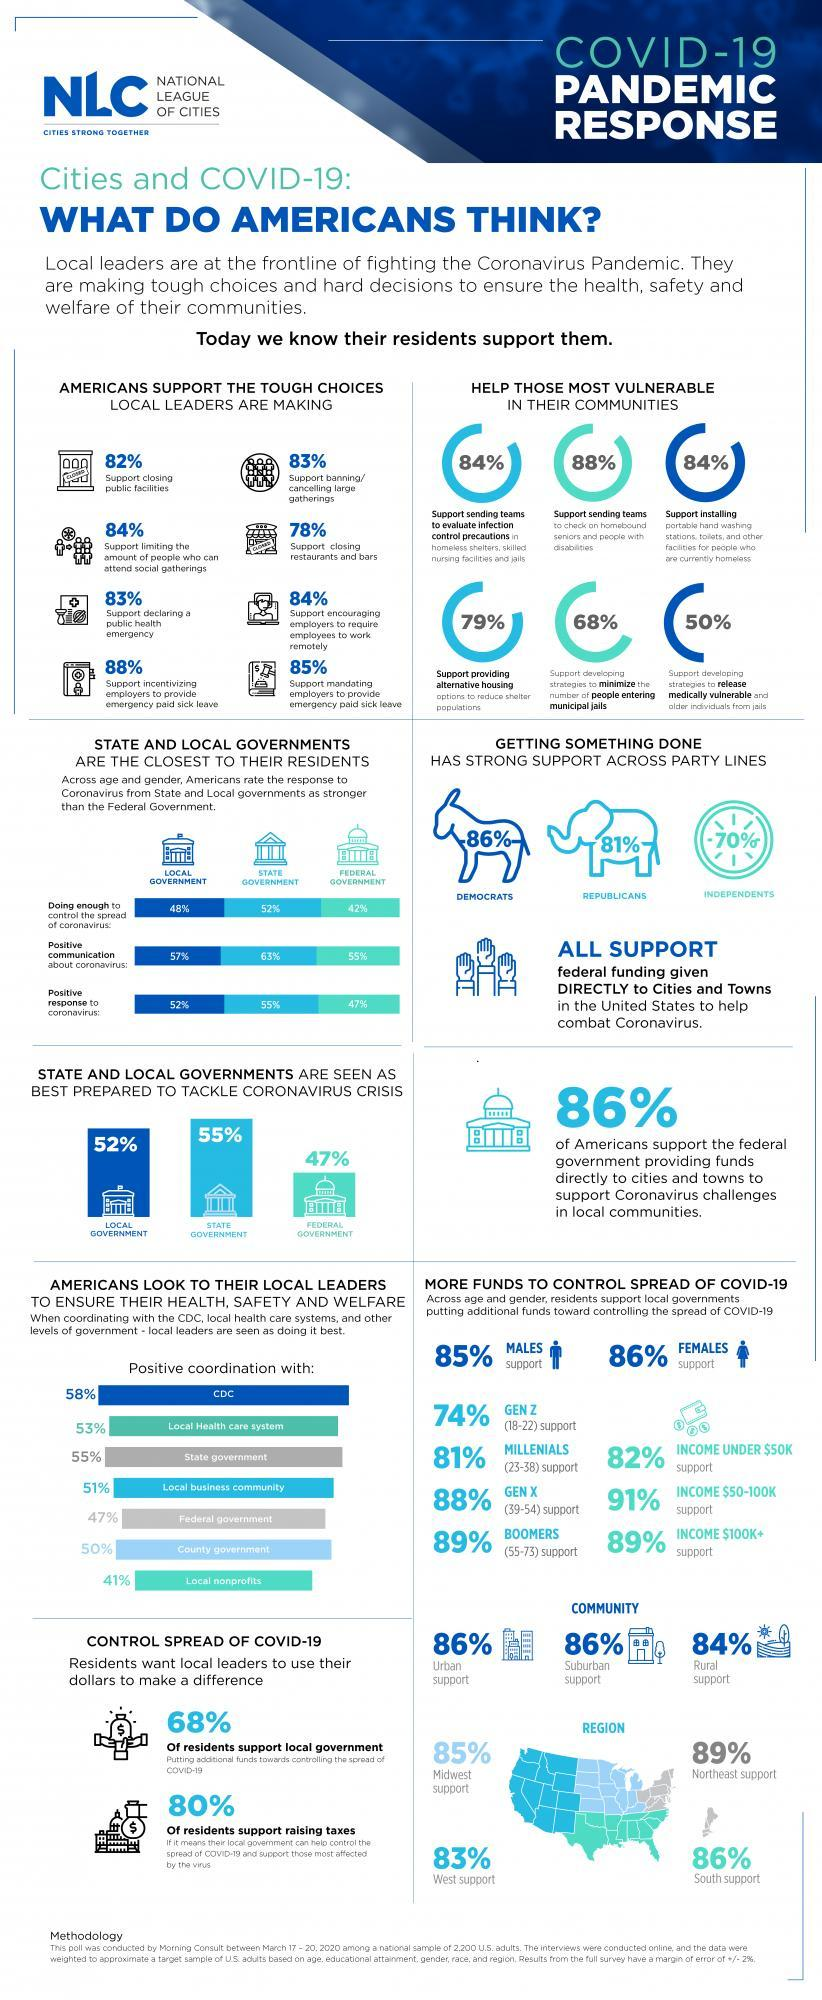What percentage of Americans thinks that the federal government not responded to coronavirus positively?
Answer the question with a short phrase. 53% what percentage of women does not support more funds to control the spread of COVID-19? 14 what percentage of generation z does not support more funds to control the spread of COVID-19? 26% What percentage of Americans thinks that the state government not responded to coronavirus positively? 48% What percentage of Americans thinks that effort taken by state government to control the spread of coronavirus is not enough? 48% What percentage of Americans thinks that effort taken by state government to control the spread of coronavirus is enough? 52 What percentage of Americans thinks that effort taken by federal government to control the spread of coronavirus is enough? 42 What percent of residents does not support raising taxes? 20 What percent of residents does not support federal government providing funds directly to cities and towns? 14 What percentage of Americans thinks that effort taken by the federal government to control the spread of coronavirus is not enough? 58% What percentage of Americans thinks that the state government not responded to coronavirus positively? 45 What percent of residents does not support declaring a public health emergency?? 17% What percent of residents does not support closing restaurants and bars? 22 What percent of residents does not support local government? 32 What percent of residents does not support closing public facilities? 18% what percentage of generation x does not support more funds to control the spread of COVID-19? 12 